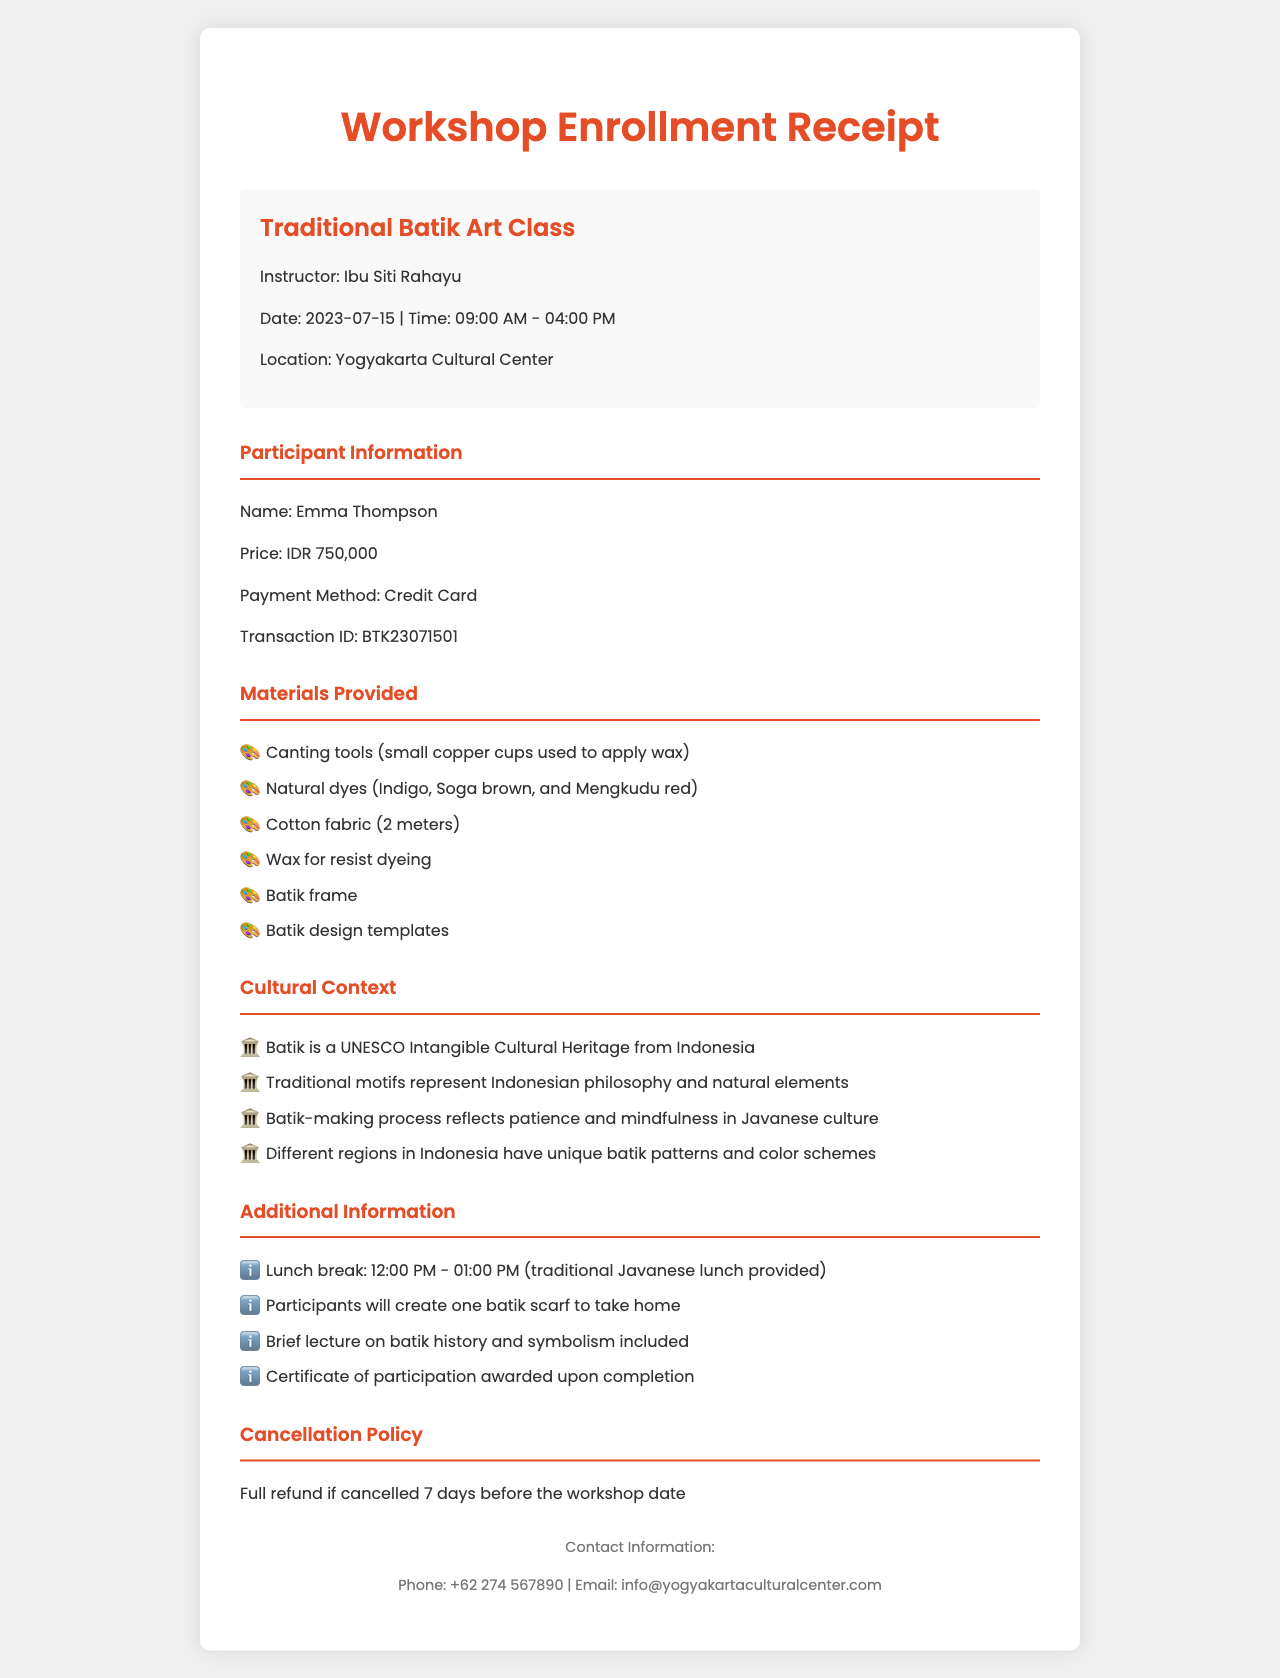What is the workshop name? The workshop name is prominently displayed at the start of the document.
Answer: Traditional Batik Art Class Who is the instructor? The instructor's name is stated right under the workshop title.
Answer: Ibu Siti Rahayu What date is the workshop scheduled for? The date of the workshop is clearly listed in the information section.
Answer: 2023-07-15 How much is the enrollment fee? The price of the workshop is indicated in the participant information section.
Answer: 750000 IDR What materials will be provided? Materials provided are listed in a specific section of the document.
Answer: Canting tools, natural dyes, cotton fabric, wax, batik frame, batik design templates What is the cultural significance of batik? The cultural context highlights the importance of batik and its heritage.
Answer: UNESCO Intangible Cultural Heritage What will participants create during the workshop? Additional information specifies what participants will make.
Answer: One batik scarf What time does the lunch break start? The lunch break time is mentioned in the additional information section.
Answer: 12:00 PM What happens if I cancel within 7 days of the workshop? The cancellation policy indicates what occurs if canceled within a specific timeframe.
Answer: No refund 